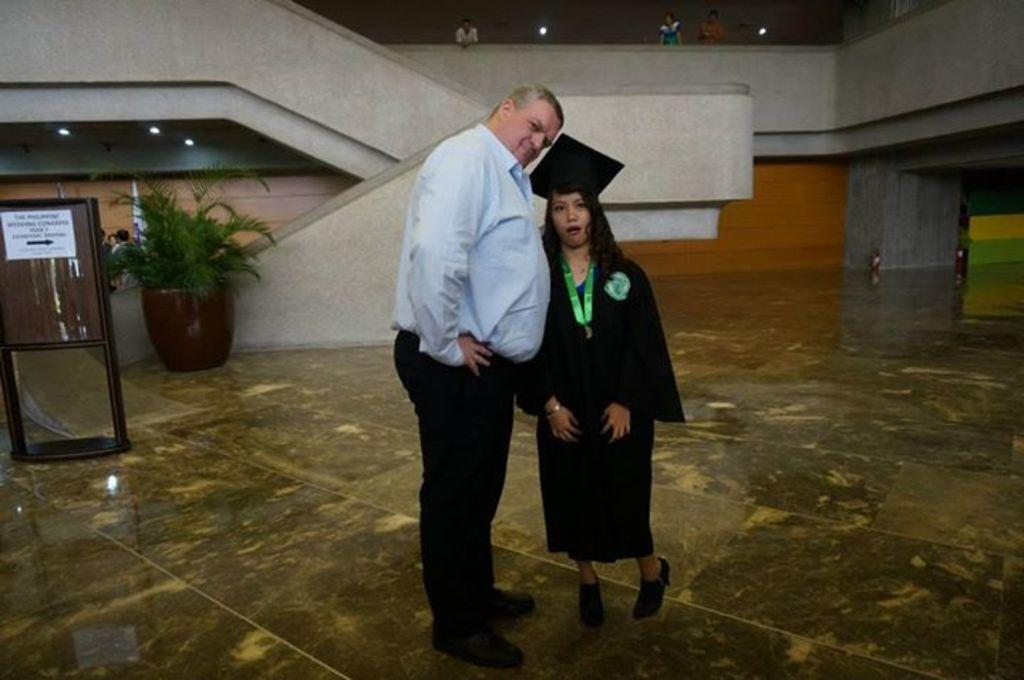How many people are visible in the image? There are two persons standing in the image. What can be seen in the background behind the two persons? There is a board with a paper and a plant in the background. Are there any other people visible in the image? Yes, there is a group of people in the background. What can be seen in the background that might provide light? There are lights in the background. What type of bedroom furniture can be seen in the image? There is no bedroom furniture present in the image. What role does the manager play in the image? There is no manager mentioned or depicted in the image. 